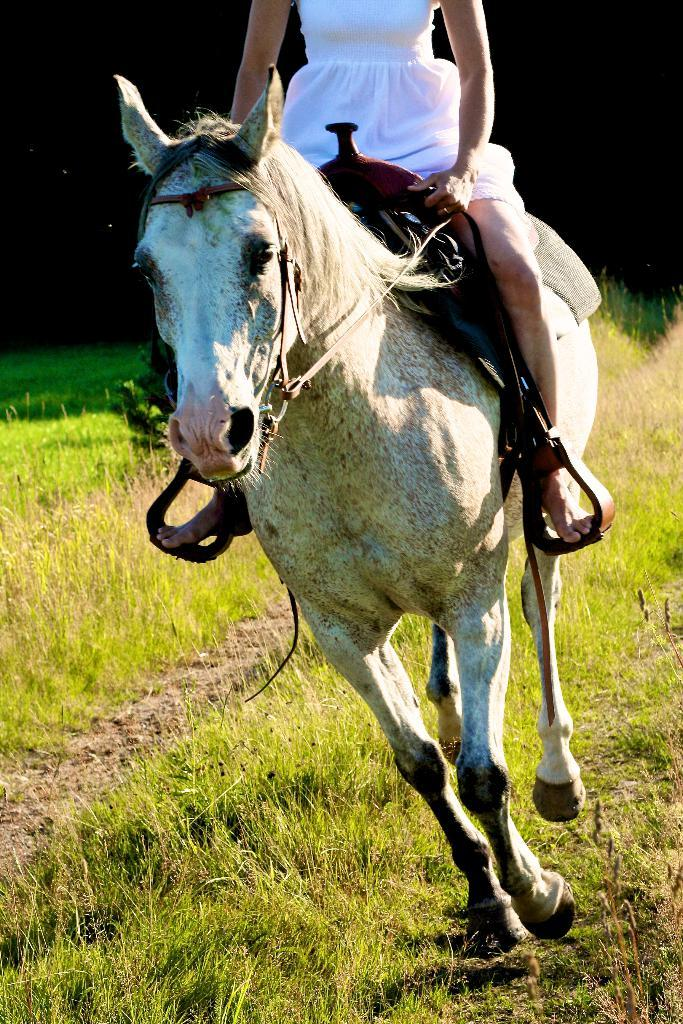Who or what is the main subject in the image? There is a person in the image. What is the person doing in the image? The person is on a horse. What type of environment is visible in the image? There is grass visible in the image. What type of plastic objects can be seen in the image? There is no plastic object present in the image. How does the person's behavior change when they see a bike in the image? There is no bike present in the image, so the person's behavior does not change in response to it. 